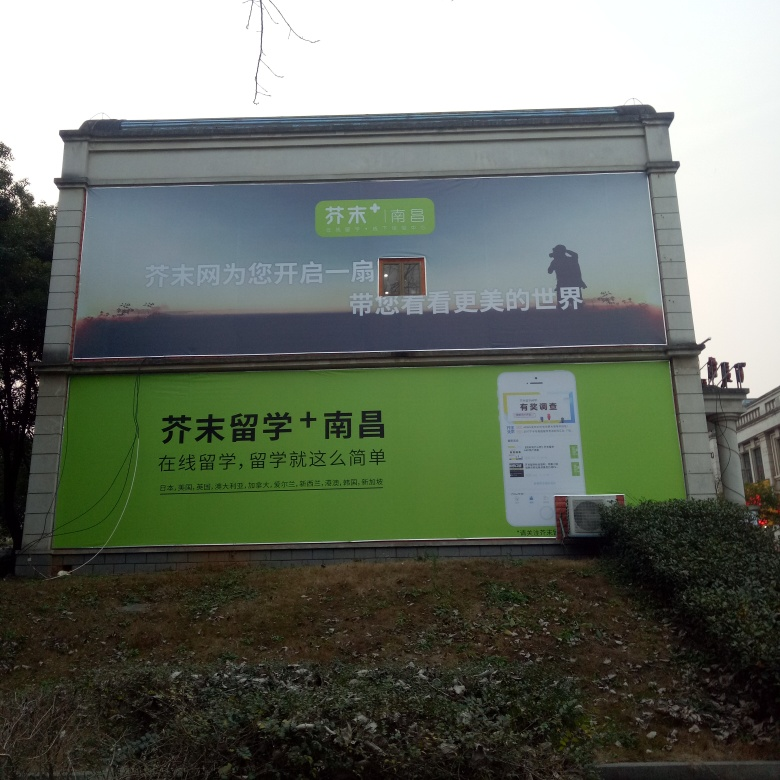What might the message of the upper part of the billboard signify with the image of the figure and landscape? The upper part of the billboard shows a silhouette of a figure in a cap, overlaid on a dusky landscape. This imagery might symbolize the ease and freedom mobile technology brings to exploring or navigating different places, tying back to the app's theme of convenience and mobility. 